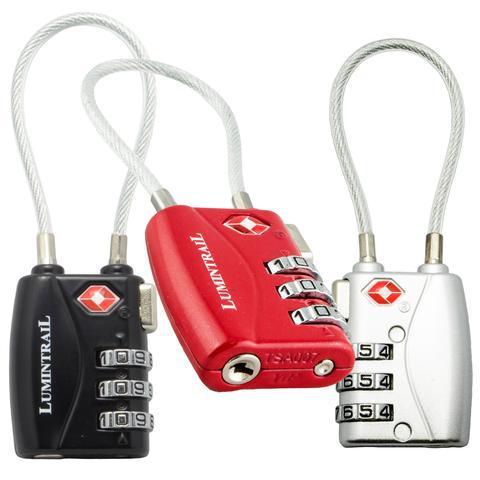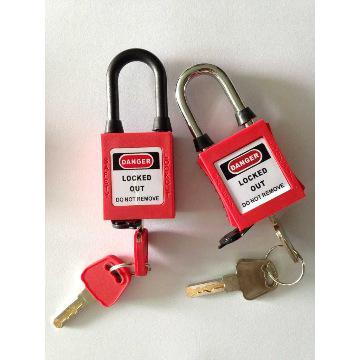The first image is the image on the left, the second image is the image on the right. For the images shown, is this caption "One of the locks on the left is black." true? Answer yes or no. Yes. 